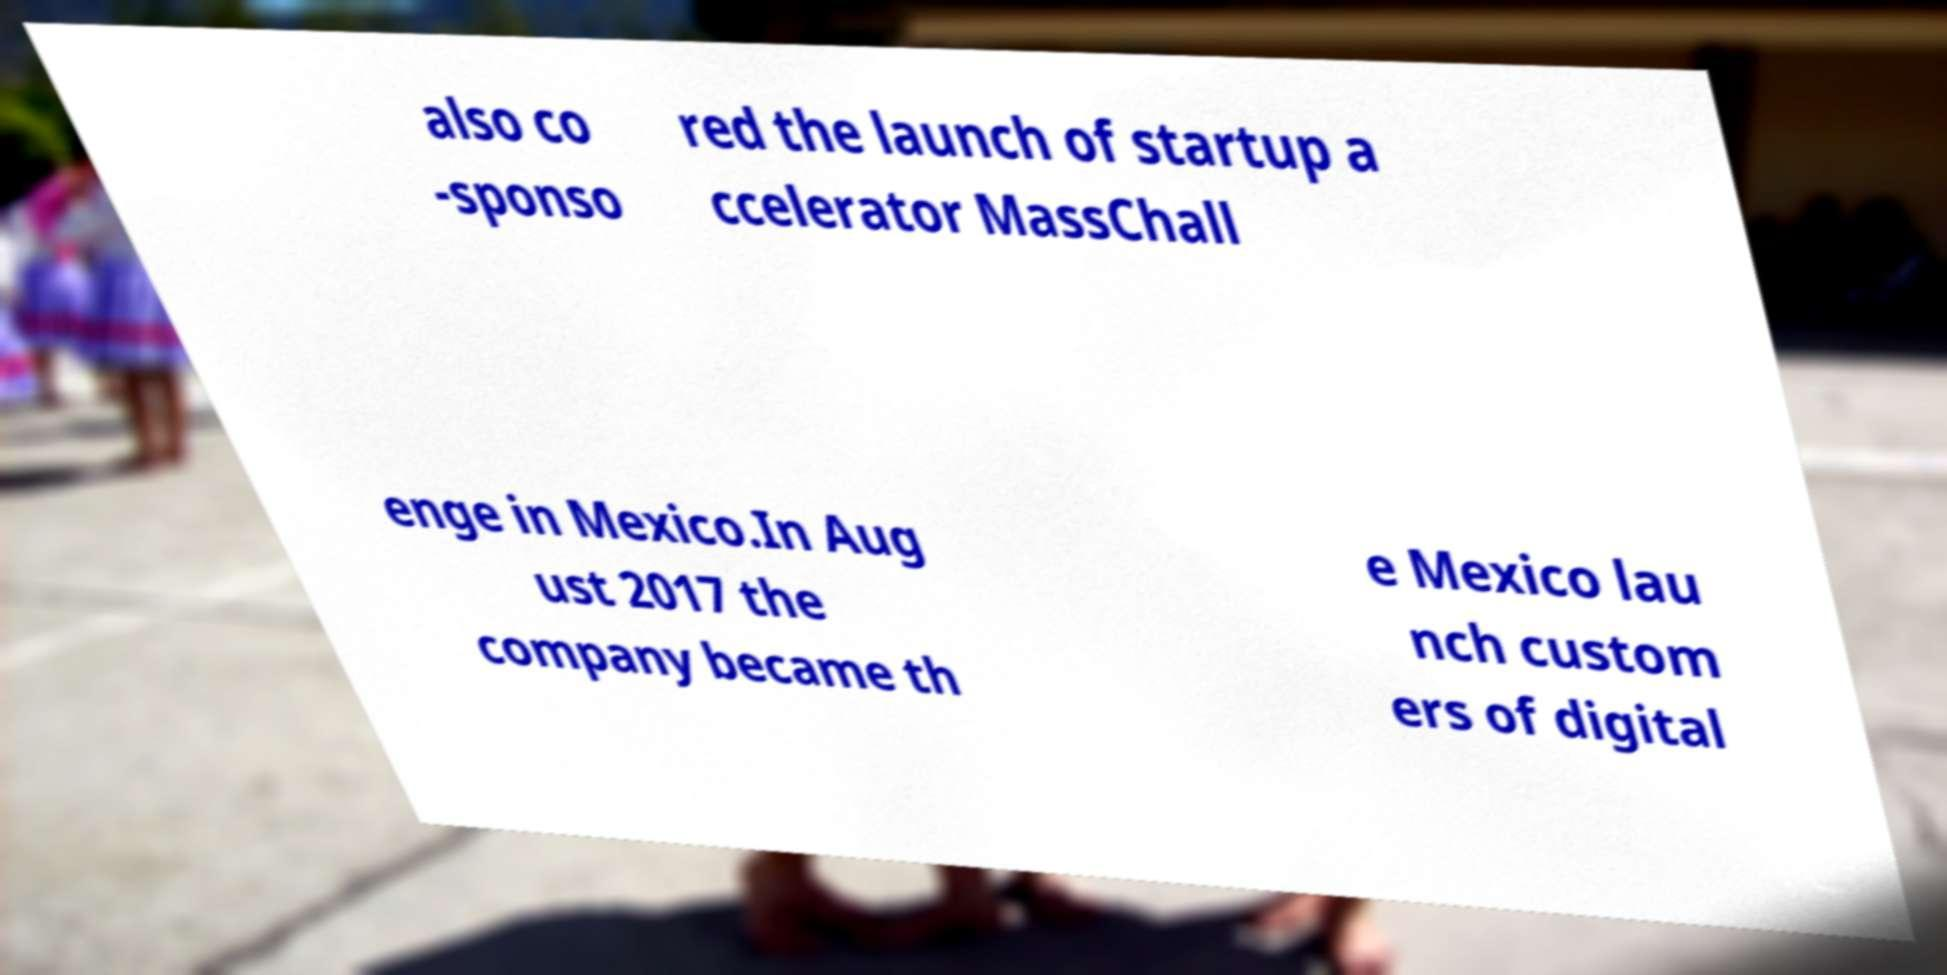Can you read and provide the text displayed in the image?This photo seems to have some interesting text. Can you extract and type it out for me? also co -sponso red the launch of startup a ccelerator MassChall enge in Mexico.In Aug ust 2017 the company became th e Mexico lau nch custom ers of digital 